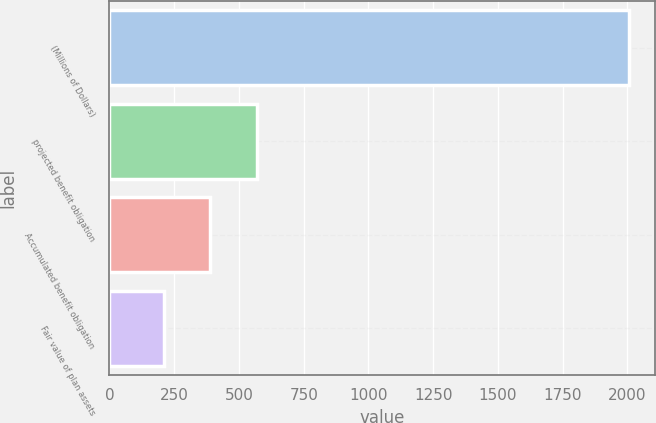Convert chart to OTSL. <chart><loc_0><loc_0><loc_500><loc_500><bar_chart><fcel>(Millions of Dollars)<fcel>projected benefit obligation<fcel>Accumulated benefit obligation<fcel>Fair value of plan assets<nl><fcel>2005<fcel>568.76<fcel>389.23<fcel>209.7<nl></chart> 